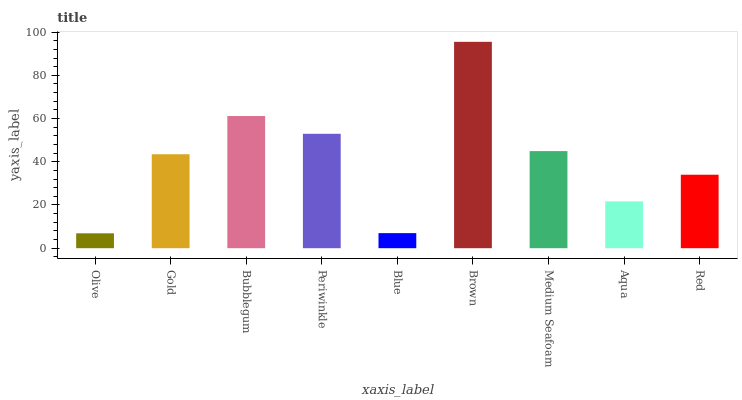Is Olive the minimum?
Answer yes or no. Yes. Is Brown the maximum?
Answer yes or no. Yes. Is Gold the minimum?
Answer yes or no. No. Is Gold the maximum?
Answer yes or no. No. Is Gold greater than Olive?
Answer yes or no. Yes. Is Olive less than Gold?
Answer yes or no. Yes. Is Olive greater than Gold?
Answer yes or no. No. Is Gold less than Olive?
Answer yes or no. No. Is Gold the high median?
Answer yes or no. Yes. Is Gold the low median?
Answer yes or no. Yes. Is Olive the high median?
Answer yes or no. No. Is Olive the low median?
Answer yes or no. No. 